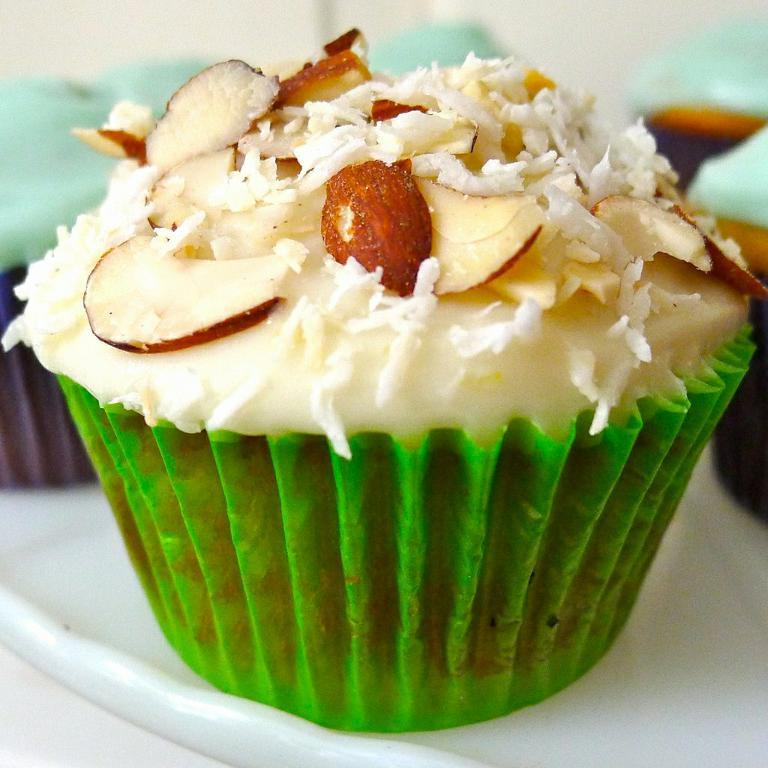What type of food is visible in the foreground of the image? There are cupcakes in a plate in the foreground of the image. Can you describe the setting in which the cupcakes are located? The image is taken in a room. What type of river can be seen flowing through the room in the image? There is no river present in the image; it is taken in a room with cupcakes in the foreground. 